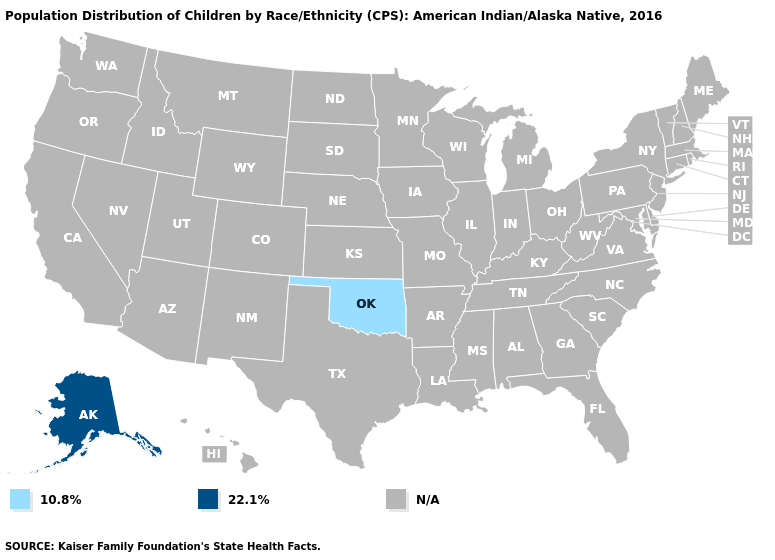Which states have the lowest value in the USA?
Short answer required. Oklahoma. How many symbols are there in the legend?
Keep it brief. 3. Name the states that have a value in the range 10.8%?
Short answer required. Oklahoma. Name the states that have a value in the range 22.1%?
Concise answer only. Alaska. Name the states that have a value in the range N/A?
Write a very short answer. Alabama, Arizona, Arkansas, California, Colorado, Connecticut, Delaware, Florida, Georgia, Hawaii, Idaho, Illinois, Indiana, Iowa, Kansas, Kentucky, Louisiana, Maine, Maryland, Massachusetts, Michigan, Minnesota, Mississippi, Missouri, Montana, Nebraska, Nevada, New Hampshire, New Jersey, New Mexico, New York, North Carolina, North Dakota, Ohio, Oregon, Pennsylvania, Rhode Island, South Carolina, South Dakota, Tennessee, Texas, Utah, Vermont, Virginia, Washington, West Virginia, Wisconsin, Wyoming. Is the legend a continuous bar?
Give a very brief answer. No. What is the value of Alaska?
Short answer required. 22.1%. What is the value of Mississippi?
Quick response, please. N/A. How many symbols are there in the legend?
Keep it brief. 3. 